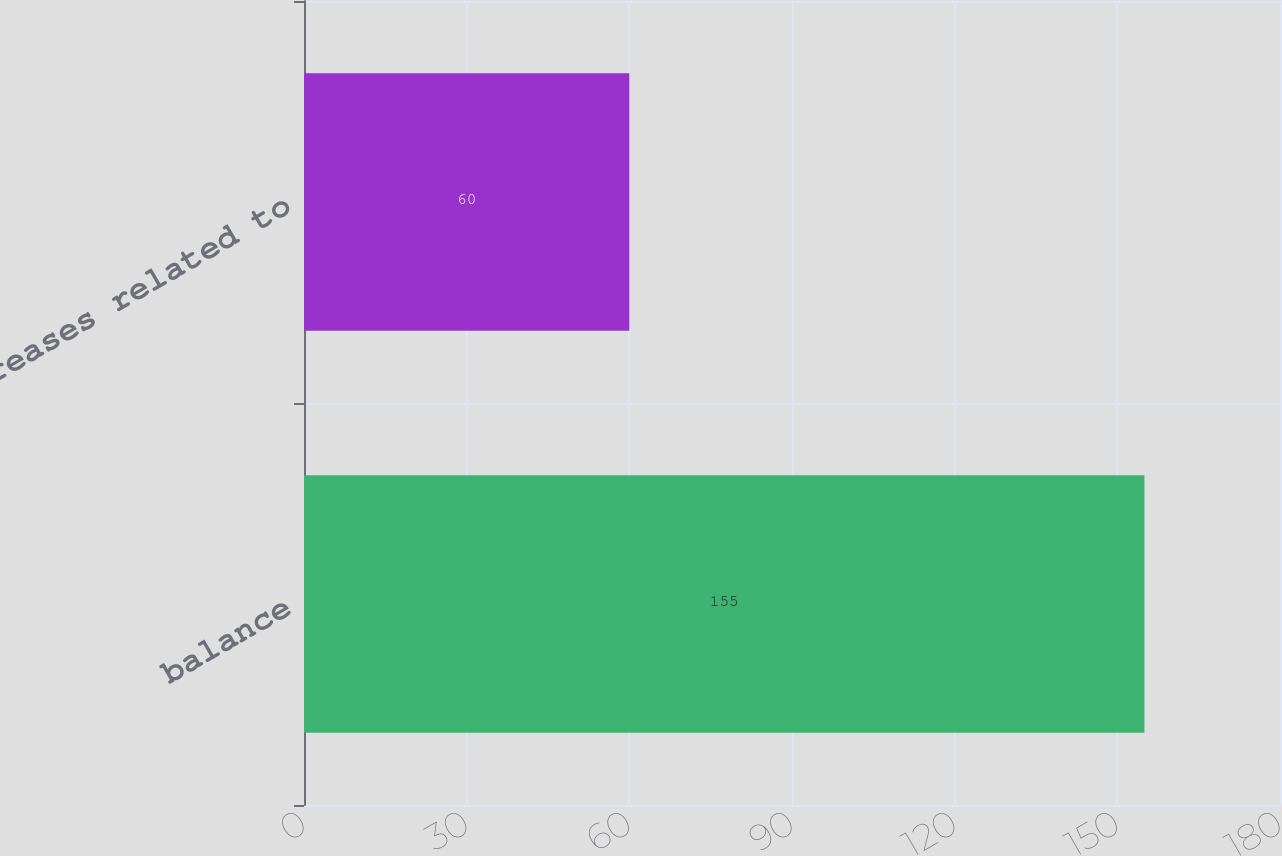<chart> <loc_0><loc_0><loc_500><loc_500><bar_chart><fcel>balance<fcel>Decreases related to<nl><fcel>155<fcel>60<nl></chart> 